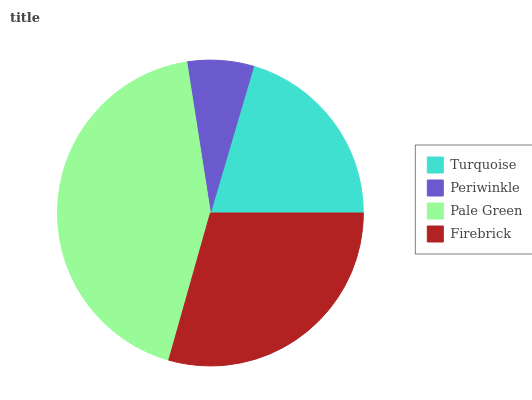Is Periwinkle the minimum?
Answer yes or no. Yes. Is Pale Green the maximum?
Answer yes or no. Yes. Is Pale Green the minimum?
Answer yes or no. No. Is Periwinkle the maximum?
Answer yes or no. No. Is Pale Green greater than Periwinkle?
Answer yes or no. Yes. Is Periwinkle less than Pale Green?
Answer yes or no. Yes. Is Periwinkle greater than Pale Green?
Answer yes or no. No. Is Pale Green less than Periwinkle?
Answer yes or no. No. Is Firebrick the high median?
Answer yes or no. Yes. Is Turquoise the low median?
Answer yes or no. Yes. Is Periwinkle the high median?
Answer yes or no. No. Is Firebrick the low median?
Answer yes or no. No. 